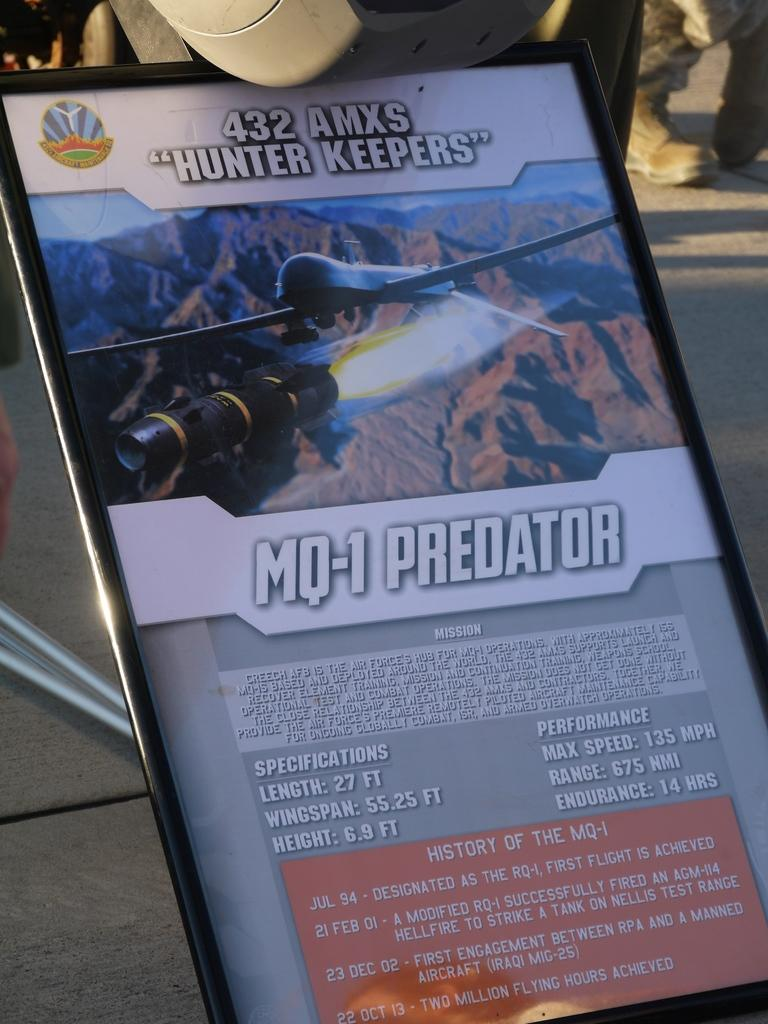<image>
Create a compact narrative representing the image presented. A display ad for the MQ-1 Predator that includes its specifications. 